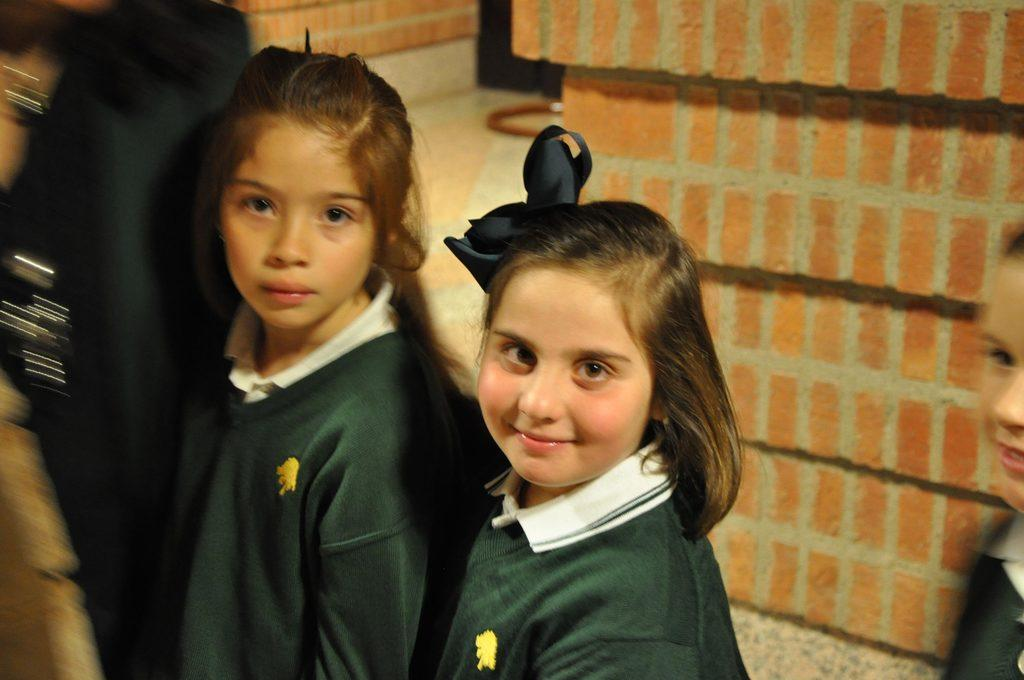What can be seen in the image? There are girls standing in the image. What is visible in the background of the image? There is a brick wall in the background of the image. What sense can be seen in the image? There is no sense visible in the image; it features girls standing and a brick wall in the background. What type of field is present in the image? There is no field present in the image; it features girls standing and a brick wall in the background. 